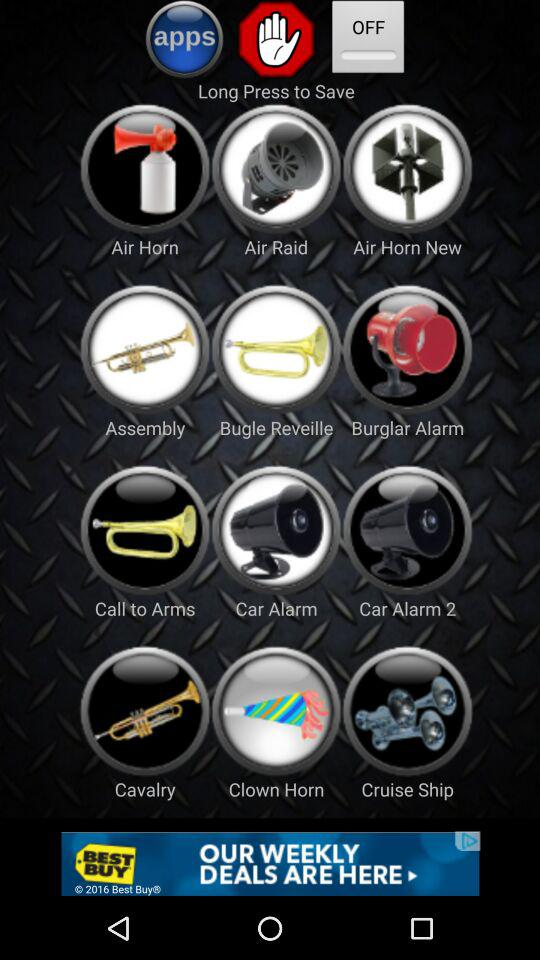What are the different sound options available? The different sound options available are "Air Horn", "Air Raid", "Air Raid New", "Assembly", "Bugle Reveille", "Burglar Alarm", "Call to Arms", "Car Alarm", "Car Alarm 2", "Cavalry", "Clown Horn" and "Cruise Ship". 